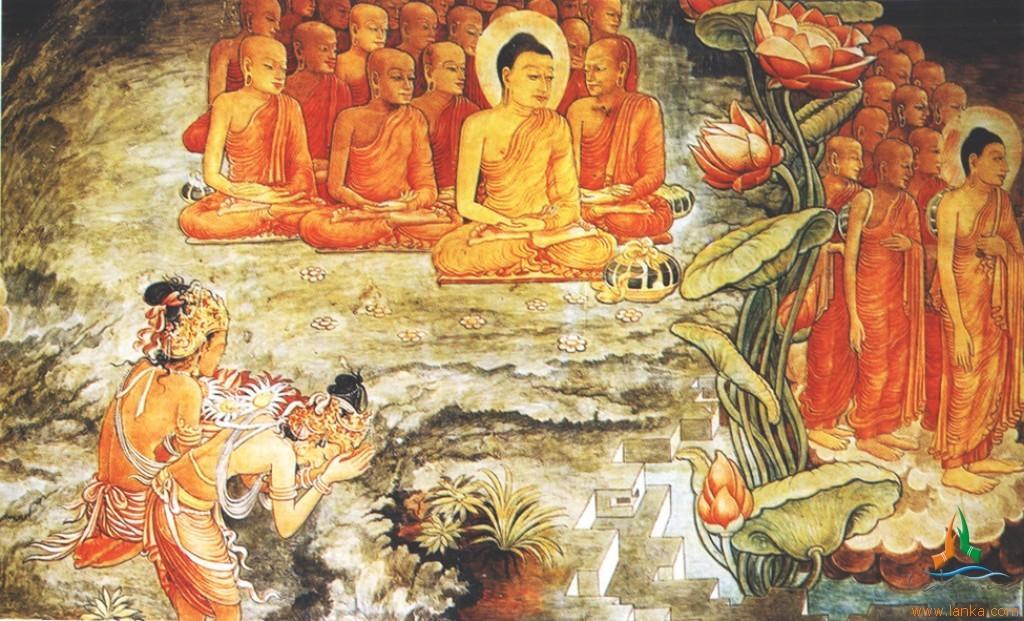In one or two sentences, can you explain what this image depicts? In this picture we can see painting of people, flowers and leaves. In the bottom right side of the image we can see text. 